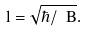<formula> <loc_0><loc_0><loc_500><loc_500>l = \sqrt { \hbar { / } \ B } .</formula> 